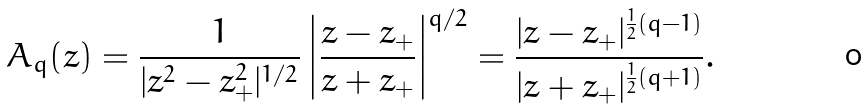Convert formula to latex. <formula><loc_0><loc_0><loc_500><loc_500>A _ { q } ( z ) = \frac { 1 } { | z ^ { 2 } - z ^ { 2 } _ { + } | ^ { 1 / 2 } } \left | \frac { z - z _ { + } } { z + z _ { + } } \right | ^ { q / 2 } = \frac { | z - z _ { + } | ^ { \frac { 1 } { 2 } ( q - 1 ) } } { | z + z _ { + } | ^ { \frac { 1 } { 2 } ( q + 1 ) } } .</formula> 